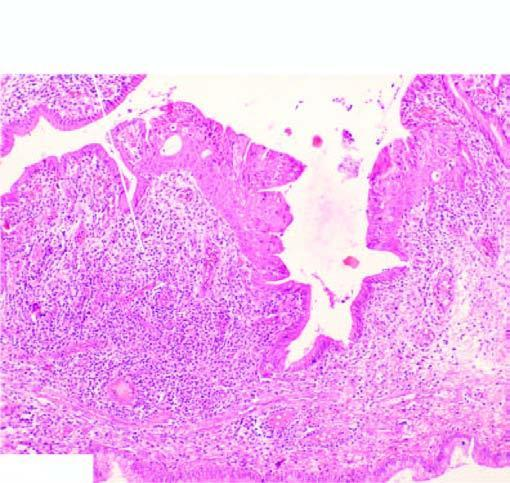s part of the endocervical mucosa lined by normal columnar epithelium while foci of metaplastic squamous epithelium are seen at other places?
Answer the question using a single word or phrase. Yes 